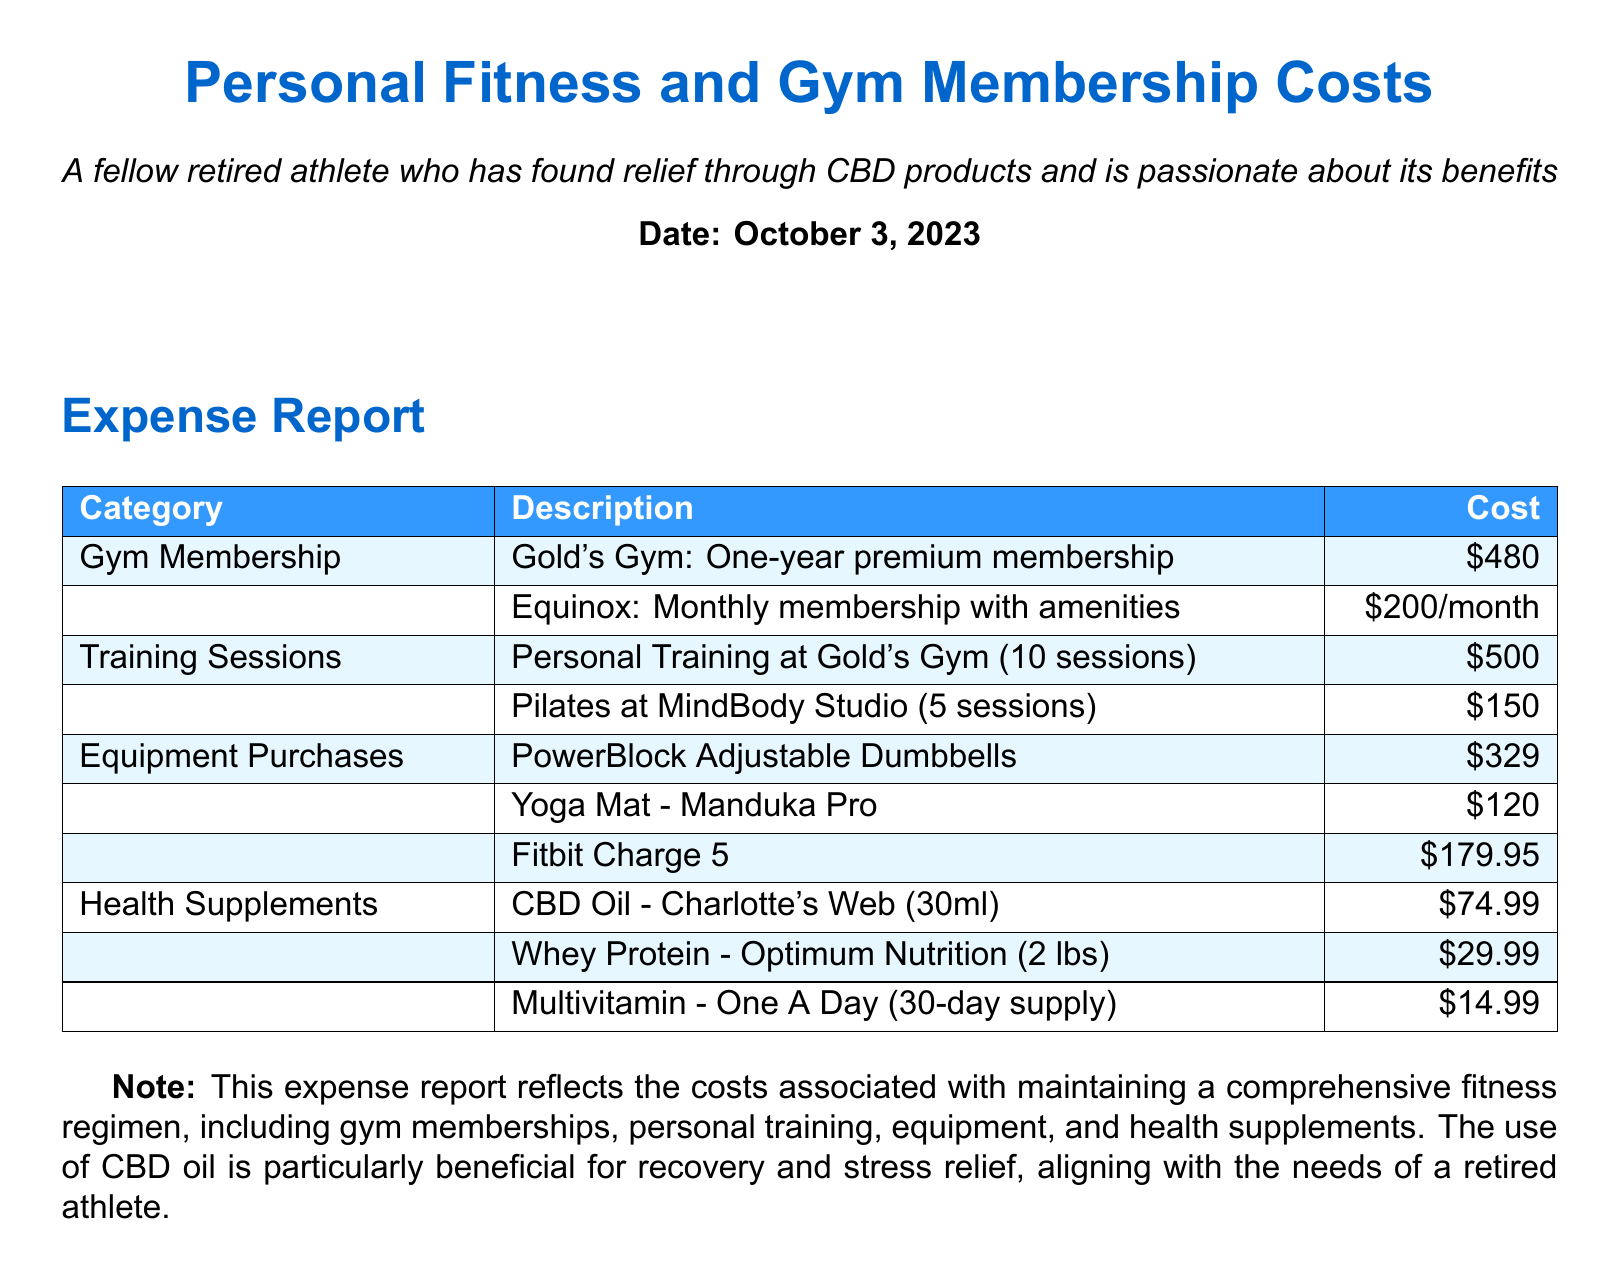What is the total cost of the gym memberships? The total cost includes a one-year premium membership at Gold's Gym for $480 and a monthly membership at Equinox for $200, totaling $480 + ($200 * 12) = $480 + $2400 = $2880.
Answer: $2880 How much did personal training sessions cost? The document states that personal training at Gold's Gym for 10 sessions costs $500.
Answer: $500 What type of equipment was purchased? The document lists several items including Adjustable Dumbbells, a Yoga Mat, and a Fitbit.
Answer: PowerBlock Adjustable Dumbbells, Yoga Mat - Manduka Pro, Fitbit Charge 5 What is the cost of the CBD Oil? The expense report indicates that CBD Oil from Charlotte's Web (30ml) costs $74.99.
Answer: $74.99 How many sessions of Pilates were taken? The report specifies that 5 sessions of Pilates were taken at MindBody Studio.
Answer: 5 sessions What is the monthly cost of the Equinox membership? According to the document, the monthly membership cost at Equinox is stated as $200/month.
Answer: $200/month What is the total cost of health supplements listed? The total cost can be calculated as $74.99 (CBD Oil) + $29.99 (Whey Protein) + $14.99 (Multivitamin) = $119.97.
Answer: $119.97 Which gym has a personal training service mentioned? The report mentions personal training at Gold's Gym.
Answer: Gold's Gym What is the date of the expense report? The document specifies that the date is October 3, 2023.
Answer: October 3, 2023 